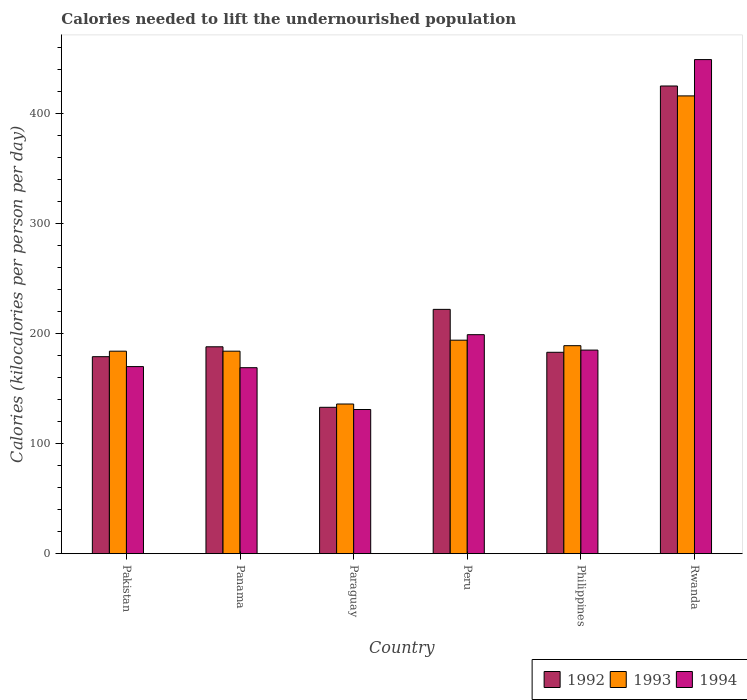How many groups of bars are there?
Provide a succinct answer. 6. Are the number of bars per tick equal to the number of legend labels?
Your answer should be very brief. Yes. Are the number of bars on each tick of the X-axis equal?
Give a very brief answer. Yes. What is the label of the 2nd group of bars from the left?
Ensure brevity in your answer.  Panama. In how many cases, is the number of bars for a given country not equal to the number of legend labels?
Your answer should be compact. 0. What is the total calories needed to lift the undernourished population in 1994 in Rwanda?
Keep it short and to the point. 449. Across all countries, what is the maximum total calories needed to lift the undernourished population in 1992?
Keep it short and to the point. 425. Across all countries, what is the minimum total calories needed to lift the undernourished population in 1992?
Provide a short and direct response. 133. In which country was the total calories needed to lift the undernourished population in 1993 maximum?
Keep it short and to the point. Rwanda. In which country was the total calories needed to lift the undernourished population in 1994 minimum?
Your response must be concise. Paraguay. What is the total total calories needed to lift the undernourished population in 1994 in the graph?
Make the answer very short. 1303. What is the difference between the total calories needed to lift the undernourished population in 1994 in Pakistan and that in Panama?
Make the answer very short. 1. What is the difference between the total calories needed to lift the undernourished population in 1993 in Peru and the total calories needed to lift the undernourished population in 1992 in Pakistan?
Provide a succinct answer. 15. What is the average total calories needed to lift the undernourished population in 1993 per country?
Your answer should be compact. 217.17. What is the difference between the total calories needed to lift the undernourished population of/in 1992 and total calories needed to lift the undernourished population of/in 1993 in Pakistan?
Your response must be concise. -5. In how many countries, is the total calories needed to lift the undernourished population in 1993 greater than 400 kilocalories?
Your response must be concise. 1. What is the ratio of the total calories needed to lift the undernourished population in 1992 in Panama to that in Philippines?
Offer a very short reply. 1.03. Is the total calories needed to lift the undernourished population in 1993 in Pakistan less than that in Philippines?
Provide a succinct answer. Yes. What is the difference between the highest and the second highest total calories needed to lift the undernourished population in 1992?
Ensure brevity in your answer.  237. What is the difference between the highest and the lowest total calories needed to lift the undernourished population in 1993?
Your answer should be compact. 280. In how many countries, is the total calories needed to lift the undernourished population in 1993 greater than the average total calories needed to lift the undernourished population in 1993 taken over all countries?
Keep it short and to the point. 1. Is it the case that in every country, the sum of the total calories needed to lift the undernourished population in 1992 and total calories needed to lift the undernourished population in 1994 is greater than the total calories needed to lift the undernourished population in 1993?
Provide a succinct answer. Yes. Are all the bars in the graph horizontal?
Offer a terse response. No. Does the graph contain any zero values?
Make the answer very short. No. Does the graph contain grids?
Provide a short and direct response. No. How many legend labels are there?
Offer a terse response. 3. What is the title of the graph?
Your answer should be very brief. Calories needed to lift the undernourished population. Does "2014" appear as one of the legend labels in the graph?
Ensure brevity in your answer.  No. What is the label or title of the Y-axis?
Make the answer very short. Calories (kilocalories per person per day). What is the Calories (kilocalories per person per day) of 1992 in Pakistan?
Provide a succinct answer. 179. What is the Calories (kilocalories per person per day) in 1993 in Pakistan?
Keep it short and to the point. 184. What is the Calories (kilocalories per person per day) of 1994 in Pakistan?
Give a very brief answer. 170. What is the Calories (kilocalories per person per day) of 1992 in Panama?
Your answer should be compact. 188. What is the Calories (kilocalories per person per day) of 1993 in Panama?
Keep it short and to the point. 184. What is the Calories (kilocalories per person per day) of 1994 in Panama?
Provide a succinct answer. 169. What is the Calories (kilocalories per person per day) of 1992 in Paraguay?
Your answer should be very brief. 133. What is the Calories (kilocalories per person per day) of 1993 in Paraguay?
Keep it short and to the point. 136. What is the Calories (kilocalories per person per day) of 1994 in Paraguay?
Offer a very short reply. 131. What is the Calories (kilocalories per person per day) of 1992 in Peru?
Keep it short and to the point. 222. What is the Calories (kilocalories per person per day) in 1993 in Peru?
Make the answer very short. 194. What is the Calories (kilocalories per person per day) of 1994 in Peru?
Your answer should be very brief. 199. What is the Calories (kilocalories per person per day) of 1992 in Philippines?
Make the answer very short. 183. What is the Calories (kilocalories per person per day) of 1993 in Philippines?
Provide a succinct answer. 189. What is the Calories (kilocalories per person per day) of 1994 in Philippines?
Provide a succinct answer. 185. What is the Calories (kilocalories per person per day) of 1992 in Rwanda?
Give a very brief answer. 425. What is the Calories (kilocalories per person per day) in 1993 in Rwanda?
Give a very brief answer. 416. What is the Calories (kilocalories per person per day) in 1994 in Rwanda?
Your answer should be very brief. 449. Across all countries, what is the maximum Calories (kilocalories per person per day) of 1992?
Make the answer very short. 425. Across all countries, what is the maximum Calories (kilocalories per person per day) in 1993?
Keep it short and to the point. 416. Across all countries, what is the maximum Calories (kilocalories per person per day) in 1994?
Your answer should be very brief. 449. Across all countries, what is the minimum Calories (kilocalories per person per day) of 1992?
Offer a terse response. 133. Across all countries, what is the minimum Calories (kilocalories per person per day) of 1993?
Your answer should be very brief. 136. Across all countries, what is the minimum Calories (kilocalories per person per day) of 1994?
Offer a terse response. 131. What is the total Calories (kilocalories per person per day) in 1992 in the graph?
Keep it short and to the point. 1330. What is the total Calories (kilocalories per person per day) of 1993 in the graph?
Provide a succinct answer. 1303. What is the total Calories (kilocalories per person per day) in 1994 in the graph?
Ensure brevity in your answer.  1303. What is the difference between the Calories (kilocalories per person per day) of 1993 in Pakistan and that in Panama?
Keep it short and to the point. 0. What is the difference between the Calories (kilocalories per person per day) of 1994 in Pakistan and that in Panama?
Ensure brevity in your answer.  1. What is the difference between the Calories (kilocalories per person per day) of 1992 in Pakistan and that in Paraguay?
Your answer should be compact. 46. What is the difference between the Calories (kilocalories per person per day) in 1993 in Pakistan and that in Paraguay?
Your answer should be very brief. 48. What is the difference between the Calories (kilocalories per person per day) of 1994 in Pakistan and that in Paraguay?
Offer a very short reply. 39. What is the difference between the Calories (kilocalories per person per day) in 1992 in Pakistan and that in Peru?
Your answer should be compact. -43. What is the difference between the Calories (kilocalories per person per day) in 1993 in Pakistan and that in Peru?
Your response must be concise. -10. What is the difference between the Calories (kilocalories per person per day) in 1992 in Pakistan and that in Philippines?
Your answer should be very brief. -4. What is the difference between the Calories (kilocalories per person per day) in 1993 in Pakistan and that in Philippines?
Provide a short and direct response. -5. What is the difference between the Calories (kilocalories per person per day) in 1992 in Pakistan and that in Rwanda?
Your answer should be very brief. -246. What is the difference between the Calories (kilocalories per person per day) in 1993 in Pakistan and that in Rwanda?
Keep it short and to the point. -232. What is the difference between the Calories (kilocalories per person per day) in 1994 in Pakistan and that in Rwanda?
Provide a short and direct response. -279. What is the difference between the Calories (kilocalories per person per day) in 1992 in Panama and that in Paraguay?
Make the answer very short. 55. What is the difference between the Calories (kilocalories per person per day) in 1993 in Panama and that in Paraguay?
Offer a terse response. 48. What is the difference between the Calories (kilocalories per person per day) of 1994 in Panama and that in Paraguay?
Keep it short and to the point. 38. What is the difference between the Calories (kilocalories per person per day) of 1992 in Panama and that in Peru?
Ensure brevity in your answer.  -34. What is the difference between the Calories (kilocalories per person per day) of 1993 in Panama and that in Peru?
Keep it short and to the point. -10. What is the difference between the Calories (kilocalories per person per day) of 1994 in Panama and that in Peru?
Provide a succinct answer. -30. What is the difference between the Calories (kilocalories per person per day) in 1994 in Panama and that in Philippines?
Give a very brief answer. -16. What is the difference between the Calories (kilocalories per person per day) in 1992 in Panama and that in Rwanda?
Make the answer very short. -237. What is the difference between the Calories (kilocalories per person per day) of 1993 in Panama and that in Rwanda?
Make the answer very short. -232. What is the difference between the Calories (kilocalories per person per day) in 1994 in Panama and that in Rwanda?
Offer a terse response. -280. What is the difference between the Calories (kilocalories per person per day) in 1992 in Paraguay and that in Peru?
Offer a terse response. -89. What is the difference between the Calories (kilocalories per person per day) of 1993 in Paraguay and that in Peru?
Keep it short and to the point. -58. What is the difference between the Calories (kilocalories per person per day) of 1994 in Paraguay and that in Peru?
Ensure brevity in your answer.  -68. What is the difference between the Calories (kilocalories per person per day) of 1992 in Paraguay and that in Philippines?
Provide a succinct answer. -50. What is the difference between the Calories (kilocalories per person per day) of 1993 in Paraguay and that in Philippines?
Your answer should be very brief. -53. What is the difference between the Calories (kilocalories per person per day) in 1994 in Paraguay and that in Philippines?
Your response must be concise. -54. What is the difference between the Calories (kilocalories per person per day) of 1992 in Paraguay and that in Rwanda?
Offer a terse response. -292. What is the difference between the Calories (kilocalories per person per day) of 1993 in Paraguay and that in Rwanda?
Offer a very short reply. -280. What is the difference between the Calories (kilocalories per person per day) in 1994 in Paraguay and that in Rwanda?
Ensure brevity in your answer.  -318. What is the difference between the Calories (kilocalories per person per day) in 1992 in Peru and that in Philippines?
Your answer should be compact. 39. What is the difference between the Calories (kilocalories per person per day) in 1993 in Peru and that in Philippines?
Provide a short and direct response. 5. What is the difference between the Calories (kilocalories per person per day) in 1994 in Peru and that in Philippines?
Your response must be concise. 14. What is the difference between the Calories (kilocalories per person per day) of 1992 in Peru and that in Rwanda?
Ensure brevity in your answer.  -203. What is the difference between the Calories (kilocalories per person per day) in 1993 in Peru and that in Rwanda?
Ensure brevity in your answer.  -222. What is the difference between the Calories (kilocalories per person per day) of 1994 in Peru and that in Rwanda?
Your answer should be very brief. -250. What is the difference between the Calories (kilocalories per person per day) in 1992 in Philippines and that in Rwanda?
Offer a terse response. -242. What is the difference between the Calories (kilocalories per person per day) of 1993 in Philippines and that in Rwanda?
Provide a short and direct response. -227. What is the difference between the Calories (kilocalories per person per day) in 1994 in Philippines and that in Rwanda?
Make the answer very short. -264. What is the difference between the Calories (kilocalories per person per day) of 1992 in Pakistan and the Calories (kilocalories per person per day) of 1994 in Panama?
Give a very brief answer. 10. What is the difference between the Calories (kilocalories per person per day) of 1993 in Pakistan and the Calories (kilocalories per person per day) of 1994 in Panama?
Offer a terse response. 15. What is the difference between the Calories (kilocalories per person per day) in 1992 in Pakistan and the Calories (kilocalories per person per day) in 1993 in Philippines?
Offer a very short reply. -10. What is the difference between the Calories (kilocalories per person per day) in 1993 in Pakistan and the Calories (kilocalories per person per day) in 1994 in Philippines?
Offer a terse response. -1. What is the difference between the Calories (kilocalories per person per day) of 1992 in Pakistan and the Calories (kilocalories per person per day) of 1993 in Rwanda?
Ensure brevity in your answer.  -237. What is the difference between the Calories (kilocalories per person per day) of 1992 in Pakistan and the Calories (kilocalories per person per day) of 1994 in Rwanda?
Provide a succinct answer. -270. What is the difference between the Calories (kilocalories per person per day) of 1993 in Pakistan and the Calories (kilocalories per person per day) of 1994 in Rwanda?
Make the answer very short. -265. What is the difference between the Calories (kilocalories per person per day) of 1992 in Panama and the Calories (kilocalories per person per day) of 1993 in Paraguay?
Make the answer very short. 52. What is the difference between the Calories (kilocalories per person per day) in 1993 in Panama and the Calories (kilocalories per person per day) in 1994 in Paraguay?
Your answer should be very brief. 53. What is the difference between the Calories (kilocalories per person per day) of 1993 in Panama and the Calories (kilocalories per person per day) of 1994 in Peru?
Keep it short and to the point. -15. What is the difference between the Calories (kilocalories per person per day) in 1992 in Panama and the Calories (kilocalories per person per day) in 1994 in Philippines?
Make the answer very short. 3. What is the difference between the Calories (kilocalories per person per day) of 1993 in Panama and the Calories (kilocalories per person per day) of 1994 in Philippines?
Make the answer very short. -1. What is the difference between the Calories (kilocalories per person per day) of 1992 in Panama and the Calories (kilocalories per person per day) of 1993 in Rwanda?
Provide a short and direct response. -228. What is the difference between the Calories (kilocalories per person per day) of 1992 in Panama and the Calories (kilocalories per person per day) of 1994 in Rwanda?
Your response must be concise. -261. What is the difference between the Calories (kilocalories per person per day) in 1993 in Panama and the Calories (kilocalories per person per day) in 1994 in Rwanda?
Ensure brevity in your answer.  -265. What is the difference between the Calories (kilocalories per person per day) of 1992 in Paraguay and the Calories (kilocalories per person per day) of 1993 in Peru?
Your answer should be very brief. -61. What is the difference between the Calories (kilocalories per person per day) of 1992 in Paraguay and the Calories (kilocalories per person per day) of 1994 in Peru?
Provide a short and direct response. -66. What is the difference between the Calories (kilocalories per person per day) of 1993 in Paraguay and the Calories (kilocalories per person per day) of 1994 in Peru?
Your answer should be very brief. -63. What is the difference between the Calories (kilocalories per person per day) of 1992 in Paraguay and the Calories (kilocalories per person per day) of 1993 in Philippines?
Offer a terse response. -56. What is the difference between the Calories (kilocalories per person per day) of 1992 in Paraguay and the Calories (kilocalories per person per day) of 1994 in Philippines?
Give a very brief answer. -52. What is the difference between the Calories (kilocalories per person per day) in 1993 in Paraguay and the Calories (kilocalories per person per day) in 1994 in Philippines?
Make the answer very short. -49. What is the difference between the Calories (kilocalories per person per day) of 1992 in Paraguay and the Calories (kilocalories per person per day) of 1993 in Rwanda?
Your response must be concise. -283. What is the difference between the Calories (kilocalories per person per day) of 1992 in Paraguay and the Calories (kilocalories per person per day) of 1994 in Rwanda?
Make the answer very short. -316. What is the difference between the Calories (kilocalories per person per day) of 1993 in Paraguay and the Calories (kilocalories per person per day) of 1994 in Rwanda?
Keep it short and to the point. -313. What is the difference between the Calories (kilocalories per person per day) in 1992 in Peru and the Calories (kilocalories per person per day) in 1993 in Rwanda?
Provide a short and direct response. -194. What is the difference between the Calories (kilocalories per person per day) in 1992 in Peru and the Calories (kilocalories per person per day) in 1994 in Rwanda?
Keep it short and to the point. -227. What is the difference between the Calories (kilocalories per person per day) of 1993 in Peru and the Calories (kilocalories per person per day) of 1994 in Rwanda?
Provide a short and direct response. -255. What is the difference between the Calories (kilocalories per person per day) of 1992 in Philippines and the Calories (kilocalories per person per day) of 1993 in Rwanda?
Keep it short and to the point. -233. What is the difference between the Calories (kilocalories per person per day) in 1992 in Philippines and the Calories (kilocalories per person per day) in 1994 in Rwanda?
Make the answer very short. -266. What is the difference between the Calories (kilocalories per person per day) of 1993 in Philippines and the Calories (kilocalories per person per day) of 1994 in Rwanda?
Provide a short and direct response. -260. What is the average Calories (kilocalories per person per day) in 1992 per country?
Provide a short and direct response. 221.67. What is the average Calories (kilocalories per person per day) in 1993 per country?
Your response must be concise. 217.17. What is the average Calories (kilocalories per person per day) of 1994 per country?
Give a very brief answer. 217.17. What is the difference between the Calories (kilocalories per person per day) in 1992 and Calories (kilocalories per person per day) in 1993 in Pakistan?
Provide a succinct answer. -5. What is the difference between the Calories (kilocalories per person per day) in 1992 and Calories (kilocalories per person per day) in 1994 in Pakistan?
Your answer should be compact. 9. What is the difference between the Calories (kilocalories per person per day) in 1993 and Calories (kilocalories per person per day) in 1994 in Pakistan?
Provide a succinct answer. 14. What is the difference between the Calories (kilocalories per person per day) in 1992 and Calories (kilocalories per person per day) in 1993 in Panama?
Provide a succinct answer. 4. What is the difference between the Calories (kilocalories per person per day) in 1992 and Calories (kilocalories per person per day) in 1994 in Panama?
Provide a succinct answer. 19. What is the difference between the Calories (kilocalories per person per day) in 1992 and Calories (kilocalories per person per day) in 1993 in Paraguay?
Provide a succinct answer. -3. What is the difference between the Calories (kilocalories per person per day) in 1993 and Calories (kilocalories per person per day) in 1994 in Paraguay?
Ensure brevity in your answer.  5. What is the difference between the Calories (kilocalories per person per day) in 1992 and Calories (kilocalories per person per day) in 1993 in Peru?
Offer a terse response. 28. What is the difference between the Calories (kilocalories per person per day) of 1992 and Calories (kilocalories per person per day) of 1993 in Philippines?
Provide a succinct answer. -6. What is the difference between the Calories (kilocalories per person per day) of 1992 and Calories (kilocalories per person per day) of 1993 in Rwanda?
Your response must be concise. 9. What is the difference between the Calories (kilocalories per person per day) in 1993 and Calories (kilocalories per person per day) in 1994 in Rwanda?
Offer a very short reply. -33. What is the ratio of the Calories (kilocalories per person per day) in 1992 in Pakistan to that in Panama?
Provide a short and direct response. 0.95. What is the ratio of the Calories (kilocalories per person per day) of 1994 in Pakistan to that in Panama?
Make the answer very short. 1.01. What is the ratio of the Calories (kilocalories per person per day) in 1992 in Pakistan to that in Paraguay?
Keep it short and to the point. 1.35. What is the ratio of the Calories (kilocalories per person per day) of 1993 in Pakistan to that in Paraguay?
Give a very brief answer. 1.35. What is the ratio of the Calories (kilocalories per person per day) of 1994 in Pakistan to that in Paraguay?
Make the answer very short. 1.3. What is the ratio of the Calories (kilocalories per person per day) in 1992 in Pakistan to that in Peru?
Make the answer very short. 0.81. What is the ratio of the Calories (kilocalories per person per day) of 1993 in Pakistan to that in Peru?
Ensure brevity in your answer.  0.95. What is the ratio of the Calories (kilocalories per person per day) of 1994 in Pakistan to that in Peru?
Offer a terse response. 0.85. What is the ratio of the Calories (kilocalories per person per day) in 1992 in Pakistan to that in Philippines?
Your response must be concise. 0.98. What is the ratio of the Calories (kilocalories per person per day) of 1993 in Pakistan to that in Philippines?
Your answer should be very brief. 0.97. What is the ratio of the Calories (kilocalories per person per day) in 1994 in Pakistan to that in Philippines?
Ensure brevity in your answer.  0.92. What is the ratio of the Calories (kilocalories per person per day) of 1992 in Pakistan to that in Rwanda?
Provide a short and direct response. 0.42. What is the ratio of the Calories (kilocalories per person per day) of 1993 in Pakistan to that in Rwanda?
Provide a succinct answer. 0.44. What is the ratio of the Calories (kilocalories per person per day) of 1994 in Pakistan to that in Rwanda?
Make the answer very short. 0.38. What is the ratio of the Calories (kilocalories per person per day) in 1992 in Panama to that in Paraguay?
Your answer should be compact. 1.41. What is the ratio of the Calories (kilocalories per person per day) in 1993 in Panama to that in Paraguay?
Your answer should be compact. 1.35. What is the ratio of the Calories (kilocalories per person per day) in 1994 in Panama to that in Paraguay?
Provide a succinct answer. 1.29. What is the ratio of the Calories (kilocalories per person per day) in 1992 in Panama to that in Peru?
Your answer should be compact. 0.85. What is the ratio of the Calories (kilocalories per person per day) in 1993 in Panama to that in Peru?
Give a very brief answer. 0.95. What is the ratio of the Calories (kilocalories per person per day) of 1994 in Panama to that in Peru?
Ensure brevity in your answer.  0.85. What is the ratio of the Calories (kilocalories per person per day) of 1992 in Panama to that in Philippines?
Provide a short and direct response. 1.03. What is the ratio of the Calories (kilocalories per person per day) of 1993 in Panama to that in Philippines?
Offer a very short reply. 0.97. What is the ratio of the Calories (kilocalories per person per day) in 1994 in Panama to that in Philippines?
Make the answer very short. 0.91. What is the ratio of the Calories (kilocalories per person per day) in 1992 in Panama to that in Rwanda?
Offer a terse response. 0.44. What is the ratio of the Calories (kilocalories per person per day) in 1993 in Panama to that in Rwanda?
Provide a succinct answer. 0.44. What is the ratio of the Calories (kilocalories per person per day) of 1994 in Panama to that in Rwanda?
Provide a succinct answer. 0.38. What is the ratio of the Calories (kilocalories per person per day) in 1992 in Paraguay to that in Peru?
Keep it short and to the point. 0.6. What is the ratio of the Calories (kilocalories per person per day) in 1993 in Paraguay to that in Peru?
Give a very brief answer. 0.7. What is the ratio of the Calories (kilocalories per person per day) in 1994 in Paraguay to that in Peru?
Your answer should be compact. 0.66. What is the ratio of the Calories (kilocalories per person per day) of 1992 in Paraguay to that in Philippines?
Make the answer very short. 0.73. What is the ratio of the Calories (kilocalories per person per day) of 1993 in Paraguay to that in Philippines?
Keep it short and to the point. 0.72. What is the ratio of the Calories (kilocalories per person per day) of 1994 in Paraguay to that in Philippines?
Ensure brevity in your answer.  0.71. What is the ratio of the Calories (kilocalories per person per day) in 1992 in Paraguay to that in Rwanda?
Your response must be concise. 0.31. What is the ratio of the Calories (kilocalories per person per day) in 1993 in Paraguay to that in Rwanda?
Give a very brief answer. 0.33. What is the ratio of the Calories (kilocalories per person per day) of 1994 in Paraguay to that in Rwanda?
Ensure brevity in your answer.  0.29. What is the ratio of the Calories (kilocalories per person per day) in 1992 in Peru to that in Philippines?
Your answer should be compact. 1.21. What is the ratio of the Calories (kilocalories per person per day) in 1993 in Peru to that in Philippines?
Provide a succinct answer. 1.03. What is the ratio of the Calories (kilocalories per person per day) of 1994 in Peru to that in Philippines?
Provide a short and direct response. 1.08. What is the ratio of the Calories (kilocalories per person per day) in 1992 in Peru to that in Rwanda?
Provide a succinct answer. 0.52. What is the ratio of the Calories (kilocalories per person per day) in 1993 in Peru to that in Rwanda?
Provide a short and direct response. 0.47. What is the ratio of the Calories (kilocalories per person per day) of 1994 in Peru to that in Rwanda?
Your answer should be compact. 0.44. What is the ratio of the Calories (kilocalories per person per day) of 1992 in Philippines to that in Rwanda?
Your response must be concise. 0.43. What is the ratio of the Calories (kilocalories per person per day) of 1993 in Philippines to that in Rwanda?
Keep it short and to the point. 0.45. What is the ratio of the Calories (kilocalories per person per day) of 1994 in Philippines to that in Rwanda?
Provide a short and direct response. 0.41. What is the difference between the highest and the second highest Calories (kilocalories per person per day) in 1992?
Your response must be concise. 203. What is the difference between the highest and the second highest Calories (kilocalories per person per day) in 1993?
Give a very brief answer. 222. What is the difference between the highest and the second highest Calories (kilocalories per person per day) of 1994?
Offer a terse response. 250. What is the difference between the highest and the lowest Calories (kilocalories per person per day) of 1992?
Your answer should be very brief. 292. What is the difference between the highest and the lowest Calories (kilocalories per person per day) in 1993?
Keep it short and to the point. 280. What is the difference between the highest and the lowest Calories (kilocalories per person per day) of 1994?
Offer a very short reply. 318. 